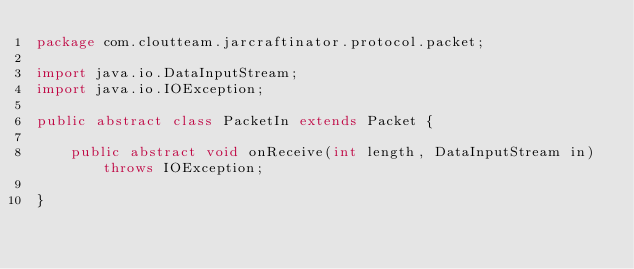Convert code to text. <code><loc_0><loc_0><loc_500><loc_500><_Java_>package com.cloutteam.jarcraftinator.protocol.packet;

import java.io.DataInputStream;
import java.io.IOException;

public abstract class PacketIn extends Packet {

    public abstract void onReceive(int length, DataInputStream in) throws IOException;

}
</code> 